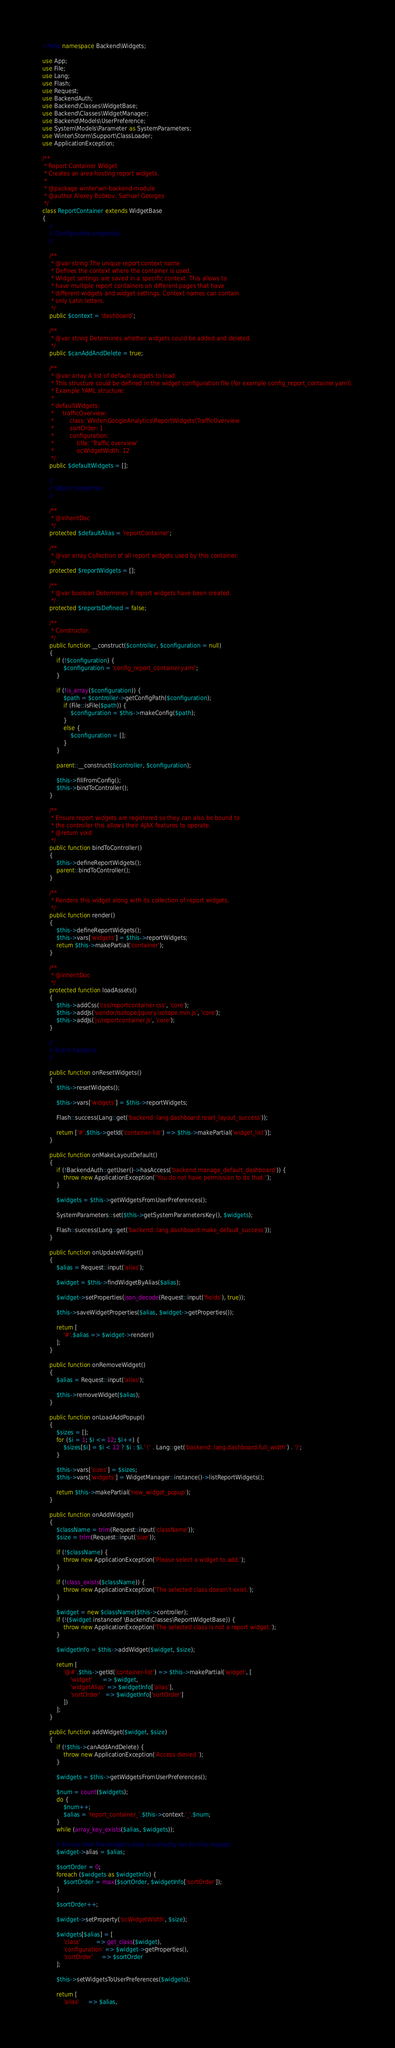<code> <loc_0><loc_0><loc_500><loc_500><_PHP_><?php namespace Backend\Widgets;

use App;
use File;
use Lang;
use Flash;
use Request;
use BackendAuth;
use Backend\Classes\WidgetBase;
use Backend\Classes\WidgetManager;
use Backend\Models\UserPreference;
use System\Models\Parameter as SystemParameters;
use Winter\Storm\Support\ClassLoader;
use ApplicationException;

/**
 * Report Container Widget
 * Creates an area hosting report widgets.
 *
 * @package winter\wn-backend-module
 * @author Alexey Bobkov, Samuel Georges
 */
class ReportContainer extends WidgetBase
{
    //
    // Configurable properties
    //

    /**
     * @var string The unique report context name
     * Defines the context where the container is used.
     * Widget settings are saved in a specific context. This allows to
     * have multiple report containers on different pages that have
     * different widgets and widget settings. Context names can contain
     * only Latin letters.
     */
    public $context = 'dashboard';

    /**
     * @var string Determines whether widgets could be added and deleted.
     */
    public $canAddAndDelete = true;

    /**
     * @var array A list of default widgets to load.
     * This structure could be defined in the widget configuration file (for example config_report_container.yaml).
     * Example YAML structure:
     *
     * defaultWidgets:
     *     trafficOverview:
     *         class: Winter\GoogleAnalytics\ReportWidgets\TrafficOverview
     *         sortOrder: 1
     *         configuration:
     *             title: 'Traffic overview'
     *             ocWidgetWidth: 12
     */
    public $defaultWidgets = [];

    //
    // Object properties
    //

    /**
     * @inheritDoc
     */
    protected $defaultAlias = 'reportContainer';

    /**
     * @var array Collection of all report widgets used by this container.
     */
    protected $reportWidgets = [];

    /**
     * @var boolean Determines if report widgets have been created.
     */
    protected $reportsDefined = false;

    /**
     * Constructor.
     */
    public function __construct($controller, $configuration = null)
    {
        if (!$configuration) {
            $configuration = 'config_report_container.yaml';
        }

        if (!is_array($configuration)) {
            $path = $controller->getConfigPath($configuration);
            if (File::isFile($path)) {
                $configuration = $this->makeConfig($path);
            }
            else {
                $configuration = [];
            }
        }

        parent::__construct($controller, $configuration);

        $this->fillFromConfig();
        $this->bindToController();
    }

    /**
     * Ensure report widgets are registered so they can also be bound to
     * the controller this allows their AJAX features to operate.
     * @return void
     */
    public function bindToController()
    {
        $this->defineReportWidgets();
        parent::bindToController();
    }

    /**
     * Renders this widget along with its collection of report widgets.
     */
    public function render()
    {
        $this->defineReportWidgets();
        $this->vars['widgets'] = $this->reportWidgets;
        return $this->makePartial('container');
    }

    /**
     * @inheritDoc
     */
    protected function loadAssets()
    {
        $this->addCss('css/reportcontainer.css', 'core');
        $this->addJs('vendor/isotope/jquery.isotope.min.js', 'core');
        $this->addJs('js/reportcontainer.js', 'core');
    }

    //
    // Event handlers
    //

    public function onResetWidgets()
    {
        $this->resetWidgets();

        $this->vars['widgets'] = $this->reportWidgets;

        Flash::success(Lang::get('backend::lang.dashboard.reset_layout_success'));

        return ['#'.$this->getId('container-list') => $this->makePartial('widget_list')];
    }

    public function onMakeLayoutDefault()
    {
        if (!BackendAuth::getUser()->hasAccess('backend.manage_default_dashboard')) {
            throw new ApplicationException("You do not have permission to do that.");
        }

        $widgets = $this->getWidgetsFromUserPreferences();

        SystemParameters::set($this->getSystemParametersKey(), $widgets);

        Flash::success(Lang::get('backend::lang.dashboard.make_default_success'));
    }

    public function onUpdateWidget()
    {
        $alias = Request::input('alias');

        $widget = $this->findWidgetByAlias($alias);

        $widget->setProperties(json_decode(Request::input('fields'), true));

        $this->saveWidgetProperties($alias, $widget->getProperties());

        return [
            '#'.$alias => $widget->render()
        ];
    }

    public function onRemoveWidget()
    {
        $alias = Request::input('alias');

        $this->removeWidget($alias);
    }

    public function onLoadAddPopup()
    {
        $sizes = [];
        for ($i = 1; $i <= 12; $i++) {
            $sizes[$i] = $i < 12 ? $i : $i.' (' . Lang::get('backend::lang.dashboard.full_width') . ')';
        }

        $this->vars['sizes'] = $sizes;
        $this->vars['widgets'] = WidgetManager::instance()->listReportWidgets();

        return $this->makePartial('new_widget_popup');
    }

    public function onAddWidget()
    {
        $className = trim(Request::input('className'));
        $size = trim(Request::input('size'));

        if (!$className) {
            throw new ApplicationException('Please select a widget to add.');
        }

        if (!class_exists($className)) {
            throw new ApplicationException('The selected class doesn\'t exist.');
        }

        $widget = new $className($this->controller);
        if (!($widget instanceof \Backend\Classes\ReportWidgetBase)) {
            throw new ApplicationException('The selected class is not a report widget.');
        }

        $widgetInfo = $this->addWidget($widget, $size);

        return [
            '@#'.$this->getId('container-list') => $this->makePartial('widget', [
                'widget'      => $widget,
                'widgetAlias' => $widgetInfo['alias'],
                'sortOrder'   => $widgetInfo['sortOrder']
            ])
        ];
    }

    public function addWidget($widget, $size)
    {
        if (!$this->canAddAndDelete) {
            throw new ApplicationException('Access denied.');
        }

        $widgets = $this->getWidgetsFromUserPreferences();

        $num = count($widgets);
        do {
            $num++;
            $alias = 'report_container_'.$this->context.'_'.$num;
        }
        while (array_key_exists($alias, $widgets));

        // Ensure that the widget's alias is correctly set for this request
        $widget->alias = $alias;

        $sortOrder = 0;
        foreach ($widgets as $widgetInfo) {
            $sortOrder = max($sortOrder, $widgetInfo['sortOrder']);
        }

        $sortOrder++;

        $widget->setProperty('ocWidgetWidth', $size);

        $widgets[$alias] = [
            'class'         => get_class($widget),
            'configuration' => $widget->getProperties(),
            'sortOrder'     => $sortOrder
        ];

        $this->setWidgetsToUserPreferences($widgets);

        return [
            'alias'     => $alias,</code> 